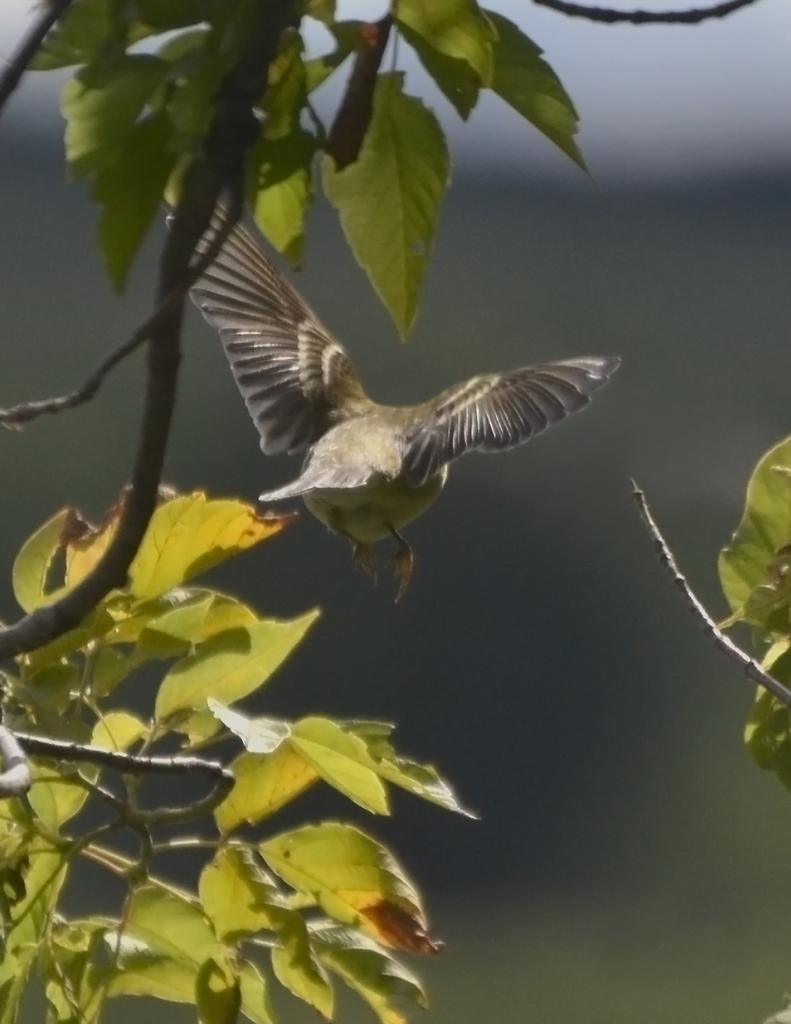What type of animal can be seen in the image? There is a bird in the image. What is the bird perched on in the image? There is a tree in the image. Can you describe the background of the image? The background of the image is blurred. What type of loaf is the bird holding in the image? There is no loaf present in the image; it features a bird perched on a tree. Is the writer playing the guitar in the image? There is no writer or guitar present in the image. 